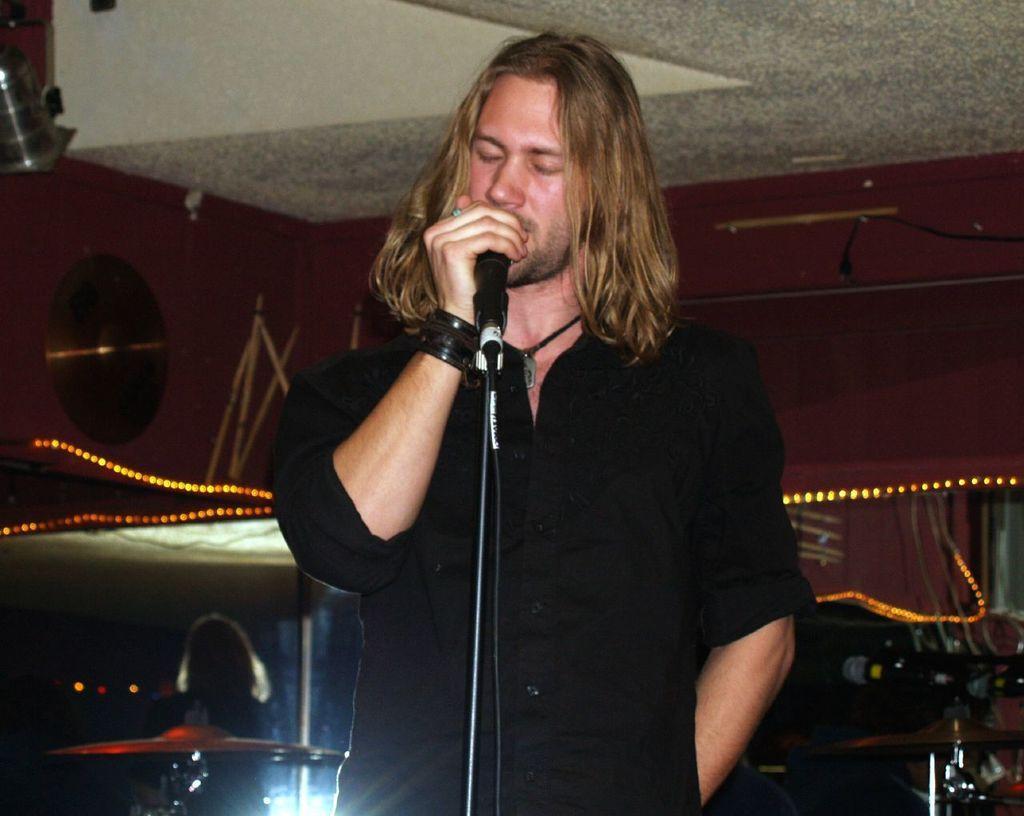Describe this image in one or two sentences. In this picture there is a man who is wearing black shirt, bands and locket. He is singing on the mic. On the bottom left corner there is another person who is standing near to the equipment. On the top we can see white color roof. On the right we can see some musical instruments, wine bottles and other objects. Here we can see light. 